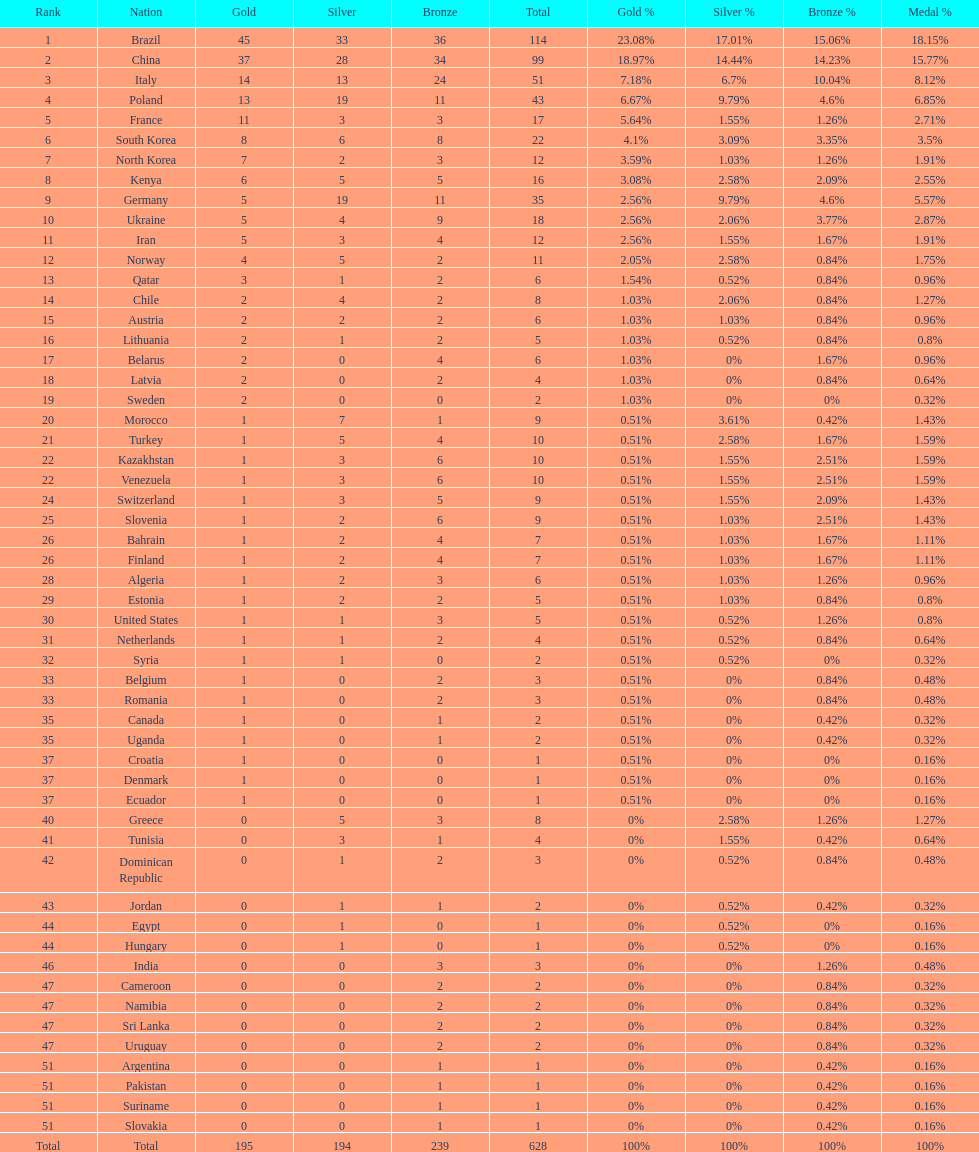Would you mind parsing the complete table? {'header': ['Rank', 'Nation', 'Gold', 'Silver', 'Bronze', 'Total', 'Gold %', 'Silver %', 'Bronze %', 'Medal %'], 'rows': [['1', 'Brazil', '45', '33', '36', '114', '23.08%', '17.01%', '15.06%', '18.15%'], ['2', 'China', '37', '28', '34', '99', '18.97%', '14.44%', '14.23%', '15.77%'], ['3', 'Italy', '14', '13', '24', '51', '7.18%', '6.7%', '10.04%', '8.12%'], ['4', 'Poland', '13', '19', '11', '43', '6.67%', '9.79%', '4.6%', '6.85%'], ['5', 'France', '11', '3', '3', '17', '5.64%', '1.55%', '1.26%', '2.71%'], ['6', 'South Korea', '8', '6', '8', '22', '4.1%', '3.09%', '3.35%', '3.5%'], ['7', 'North Korea', '7', '2', '3', '12', '3.59%', '1.03%', '1.26%', '1.91%'], ['8', 'Kenya', '6', '5', '5', '16', '3.08%', '2.58%', '2.09%', '2.55%'], ['9', 'Germany', '5', '19', '11', '35', '2.56%', '9.79%', '4.6%', '5.57%'], ['10', 'Ukraine', '5', '4', '9', '18', '2.56%', '2.06%', '3.77%', '2.87%'], ['11', 'Iran', '5', '3', '4', '12', '2.56%', '1.55%', '1.67%', '1.91%'], ['12', 'Norway', '4', '5', '2', '11', '2.05%', '2.58%', '0.84%', '1.75%'], ['13', 'Qatar', '3', '1', '2', '6', '1.54%', '0.52%', '0.84%', '0.96%'], ['14', 'Chile', '2', '4', '2', '8', '1.03%', '2.06%', '0.84%', '1.27%'], ['15', 'Austria', '2', '2', '2', '6', '1.03%', '1.03%', '0.84%', '0.96%'], ['16', 'Lithuania', '2', '1', '2', '5', '1.03%', '0.52%', '0.84%', '0.8%'], ['17', 'Belarus', '2', '0', '4', '6', '1.03%', '0%', '1.67%', '0.96%'], ['18', 'Latvia', '2', '0', '2', '4', '1.03%', '0%', '0.84%', '0.64%'], ['19', 'Sweden', '2', '0', '0', '2', '1.03%', '0%', '0%', '0.32%'], ['20', 'Morocco', '1', '7', '1', '9', '0.51%', '3.61%', '0.42%', '1.43%'], ['21', 'Turkey', '1', '5', '4', '10', '0.51%', '2.58%', '1.67%', '1.59%'], ['22', 'Kazakhstan', '1', '3', '6', '10', '0.51%', '1.55%', '2.51%', '1.59%'], ['22', 'Venezuela', '1', '3', '6', '10', '0.51%', '1.55%', '2.51%', '1.59%'], ['24', 'Switzerland', '1', '3', '5', '9', '0.51%', '1.55%', '2.09%', '1.43%'], ['25', 'Slovenia', '1', '2', '6', '9', '0.51%', '1.03%', '2.51%', '1.43%'], ['26', 'Bahrain', '1', '2', '4', '7', '0.51%', '1.03%', '1.67%', '1.11%'], ['26', 'Finland', '1', '2', '4', '7', '0.51%', '1.03%', '1.67%', '1.11%'], ['28', 'Algeria', '1', '2', '3', '6', '0.51%', '1.03%', '1.26%', '0.96%'], ['29', 'Estonia', '1', '2', '2', '5', '0.51%', '1.03%', '0.84%', '0.8%'], ['30', 'United States', '1', '1', '3', '5', '0.51%', '0.52%', '1.26%', '0.8%'], ['31', 'Netherlands', '1', '1', '2', '4', '0.51%', '0.52%', '0.84%', '0.64%'], ['32', 'Syria', '1', '1', '0', '2', '0.51%', '0.52%', '0%', '0.32%'], ['33', 'Belgium', '1', '0', '2', '3', '0.51%', '0%', '0.84%', '0.48%'], ['33', 'Romania', '1', '0', '2', '3', '0.51%', '0%', '0.84%', '0.48%'], ['35', 'Canada', '1', '0', '1', '2', '0.51%', '0%', '0.42%', '0.32%'], ['35', 'Uganda', '1', '0', '1', '2', '0.51%', '0%', '0.42%', '0.32%'], ['37', 'Croatia', '1', '0', '0', '1', '0.51%', '0%', '0%', '0.16%'], ['37', 'Denmark', '1', '0', '0', '1', '0.51%', '0%', '0%', '0.16%'], ['37', 'Ecuador', '1', '0', '0', '1', '0.51%', '0%', '0%', '0.16%'], ['40', 'Greece', '0', '5', '3', '8', '0%', '2.58%', '1.26%', '1.27%'], ['41', 'Tunisia', '0', '3', '1', '4', '0%', '1.55%', '0.42%', '0.64%'], ['42', 'Dominican Republic', '0', '1', '2', '3', '0%', '0.52%', '0.84%', '0.48%'], ['43', 'Jordan', '0', '1', '1', '2', '0%', '0.52%', '0.42%', '0.32%'], ['44', 'Egypt', '0', '1', '0', '1', '0%', '0.52%', '0%', '0.16%'], ['44', 'Hungary', '0', '1', '0', '1', '0%', '0.52%', '0%', '0.16%'], ['46', 'India', '0', '0', '3', '3', '0%', '0%', '1.26%', '0.48%'], ['47', 'Cameroon', '0', '0', '2', '2', '0%', '0%', '0.84%', '0.32%'], ['47', 'Namibia', '0', '0', '2', '2', '0%', '0%', '0.84%', '0.32%'], ['47', 'Sri Lanka', '0', '0', '2', '2', '0%', '0%', '0.84%', '0.32%'], ['47', 'Uruguay', '0', '0', '2', '2', '0%', '0%', '0.84%', '0.32%'], ['51', 'Argentina', '0', '0', '1', '1', '0%', '0%', '0.42%', '0.16%'], ['51', 'Pakistan', '0', '0', '1', '1', '0%', '0%', '0.42%', '0.16%'], ['51', 'Suriname', '0', '0', '1', '1', '0%', '0%', '0.42%', '0.16%'], ['51', 'Slovakia', '0', '0', '1', '1', '0%', '0%', '0.42%', '0.16%'], ['Total', 'Total', '195', '194', '239', '628', '100%', '100%', '100%', '100%']]} Which nation earned the most gold medals? Brazil. 